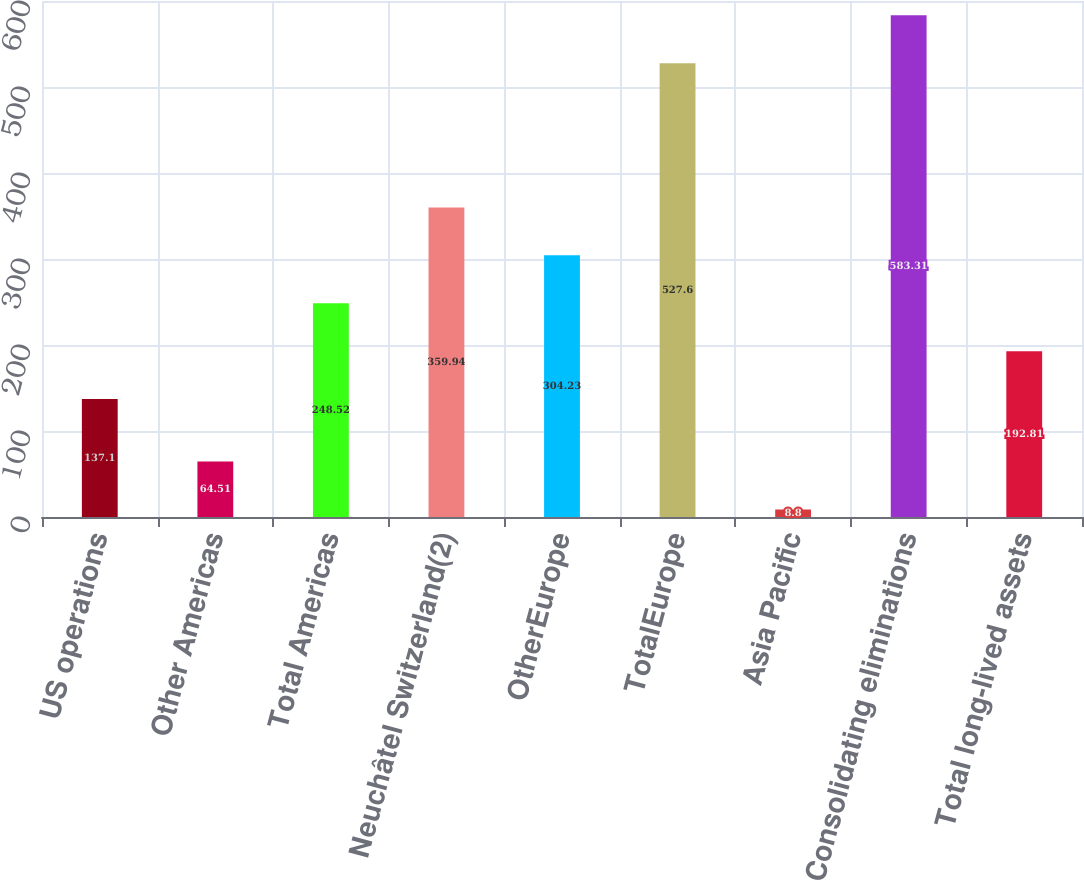Convert chart. <chart><loc_0><loc_0><loc_500><loc_500><bar_chart><fcel>US operations<fcel>Other Americas<fcel>Total Americas<fcel>Neuchâtel Switzerland(2)<fcel>OtherEurope<fcel>TotalEurope<fcel>Asia Pacific<fcel>Consolidating eliminations<fcel>Total long-lived assets<nl><fcel>137.1<fcel>64.51<fcel>248.52<fcel>359.94<fcel>304.23<fcel>527.6<fcel>8.8<fcel>583.31<fcel>192.81<nl></chart> 